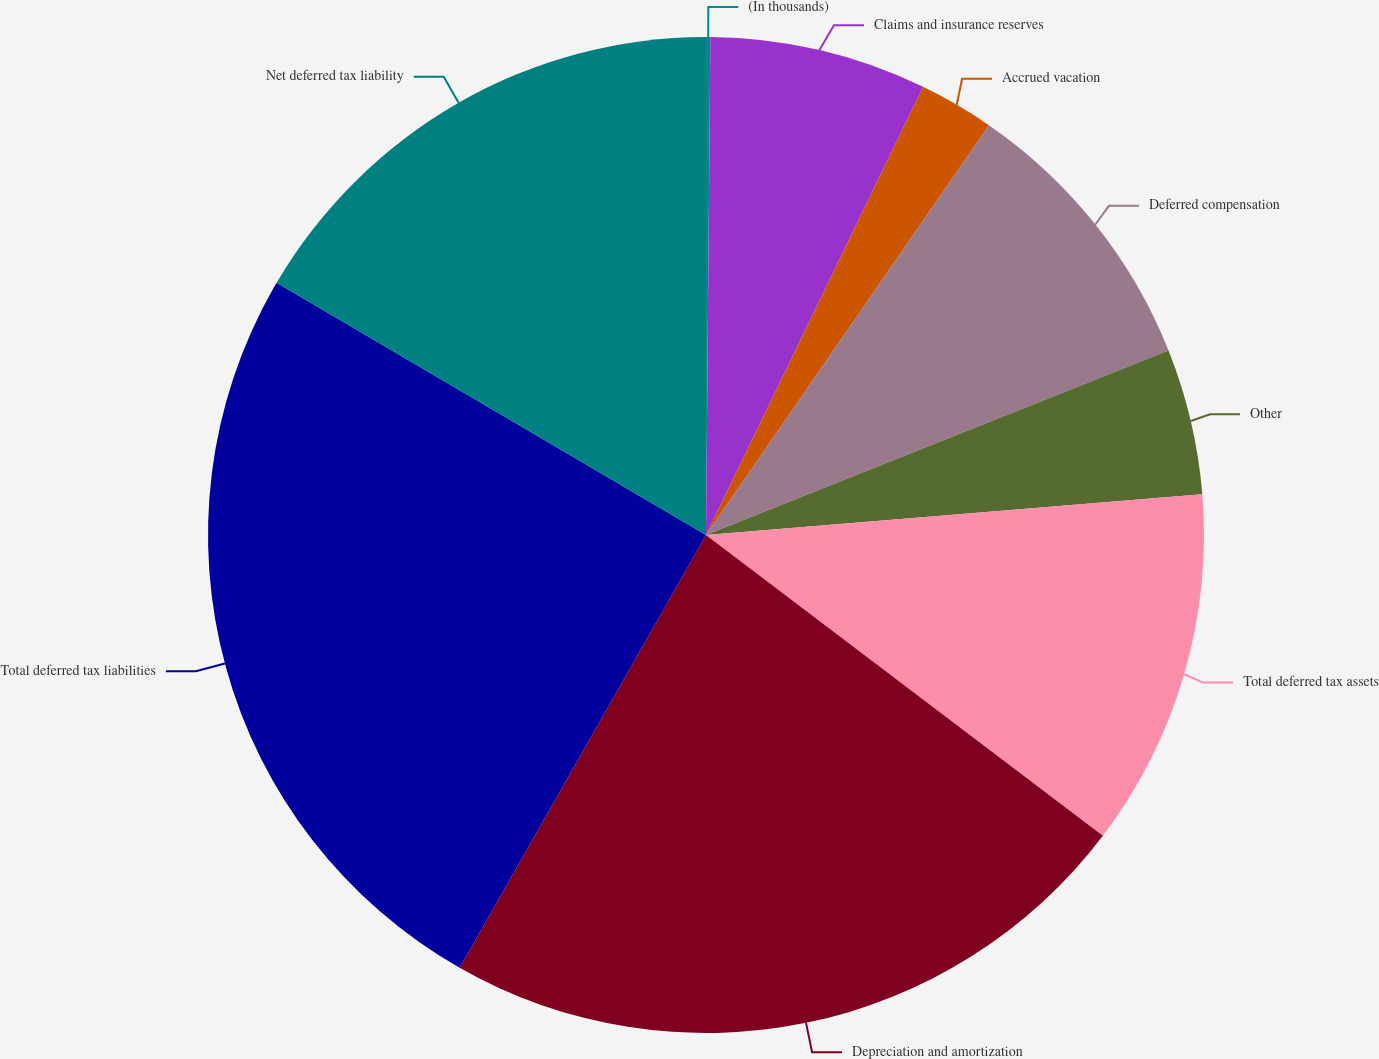Convert chart to OTSL. <chart><loc_0><loc_0><loc_500><loc_500><pie_chart><fcel>(In thousands)<fcel>Claims and insurance reserves<fcel>Accrued vacation<fcel>Deferred compensation<fcel>Other<fcel>Total deferred tax assets<fcel>Depreciation and amortization<fcel>Total deferred tax liabilities<fcel>Net deferred tax liability<nl><fcel>0.14%<fcel>7.04%<fcel>2.44%<fcel>9.34%<fcel>4.74%<fcel>11.63%<fcel>22.92%<fcel>25.22%<fcel>16.55%<nl></chart> 